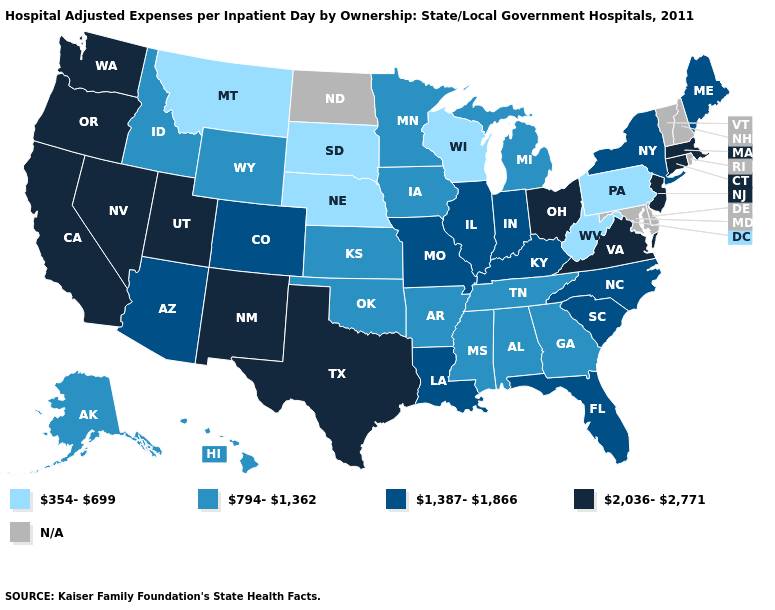Does West Virginia have the lowest value in the South?
Answer briefly. Yes. Name the states that have a value in the range 794-1,362?
Give a very brief answer. Alabama, Alaska, Arkansas, Georgia, Hawaii, Idaho, Iowa, Kansas, Michigan, Minnesota, Mississippi, Oklahoma, Tennessee, Wyoming. Among the states that border Alabama , which have the highest value?
Short answer required. Florida. What is the lowest value in the West?
Quick response, please. 354-699. What is the value of Mississippi?
Answer briefly. 794-1,362. What is the value of Kentucky?
Keep it brief. 1,387-1,866. What is the lowest value in the USA?
Write a very short answer. 354-699. What is the value of New Mexico?
Short answer required. 2,036-2,771. Does California have the highest value in the West?
Answer briefly. Yes. What is the value of Maryland?
Quick response, please. N/A. How many symbols are there in the legend?
Give a very brief answer. 5. Does the first symbol in the legend represent the smallest category?
Keep it brief. Yes. Does the map have missing data?
Quick response, please. Yes. Which states hav the highest value in the MidWest?
Keep it brief. Ohio. 